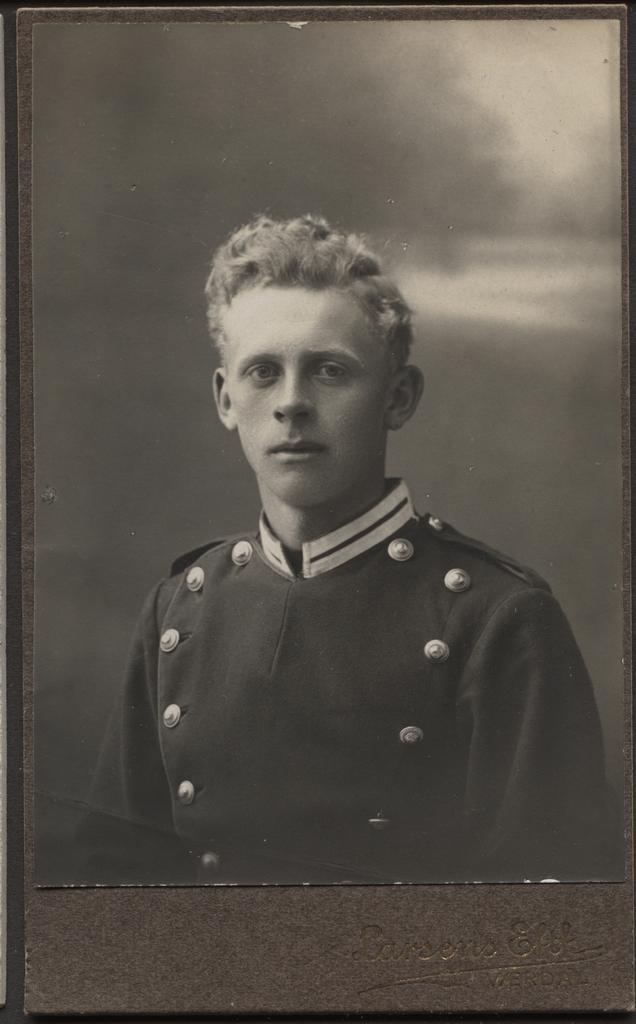How would you summarize this image in a sentence or two? In this picture we can see a photo, in this photo we can see a man and sky. 